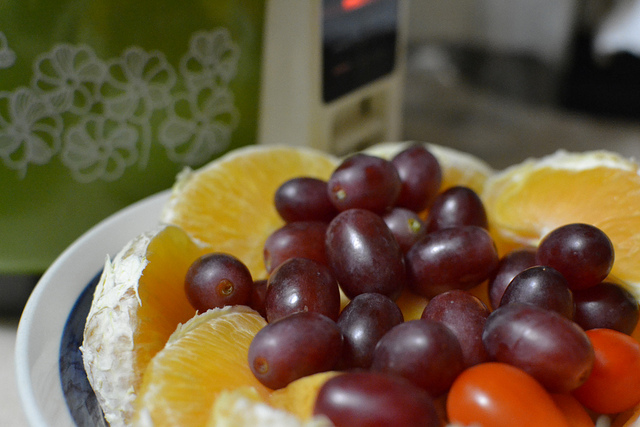<image>Which fruit has a visible stem? I don't know which fruit has a visible stem. It can be grape, but some answer indicating there is no fruit with a visible stem. Which fruit has a visible stem? I don't know which fruit has a visible stem. It can be either grape or none of them. 